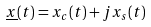<formula> <loc_0><loc_0><loc_500><loc_500>\underline { x } ( t ) = x _ { c } ( t ) + j x _ { s } ( t )</formula> 